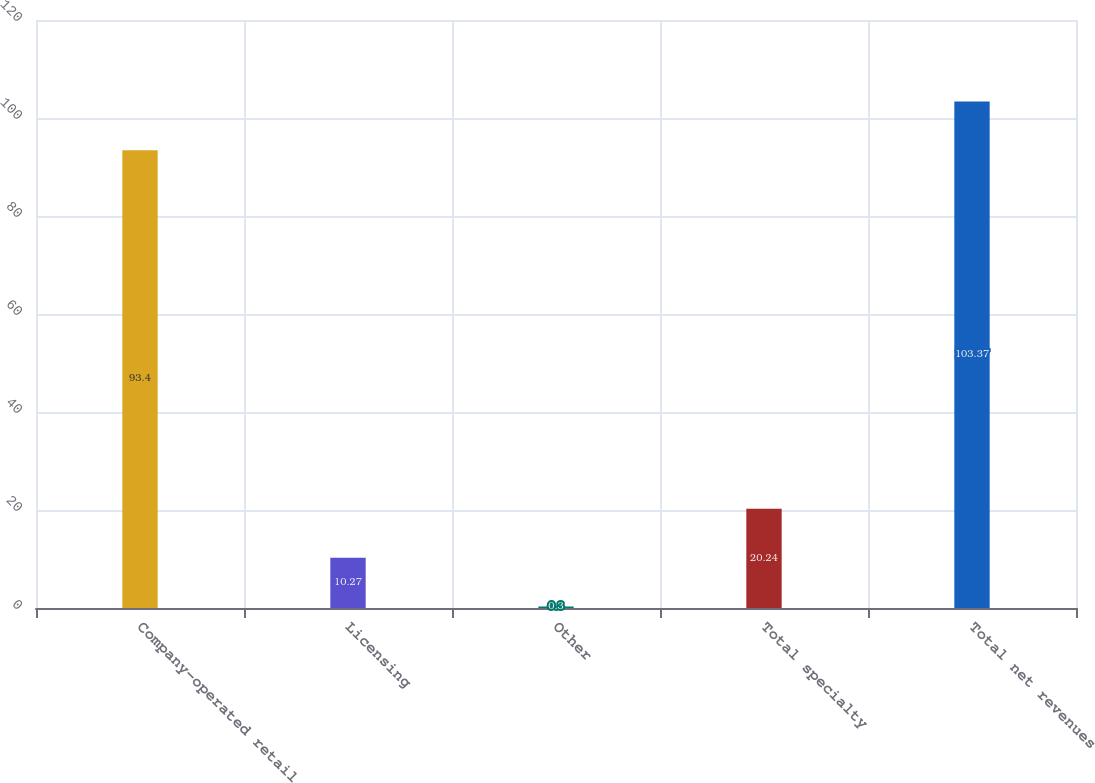Convert chart to OTSL. <chart><loc_0><loc_0><loc_500><loc_500><bar_chart><fcel>Company-operated retail<fcel>Licensing<fcel>Other<fcel>Total specialty<fcel>Total net revenues<nl><fcel>93.4<fcel>10.27<fcel>0.3<fcel>20.24<fcel>103.37<nl></chart> 